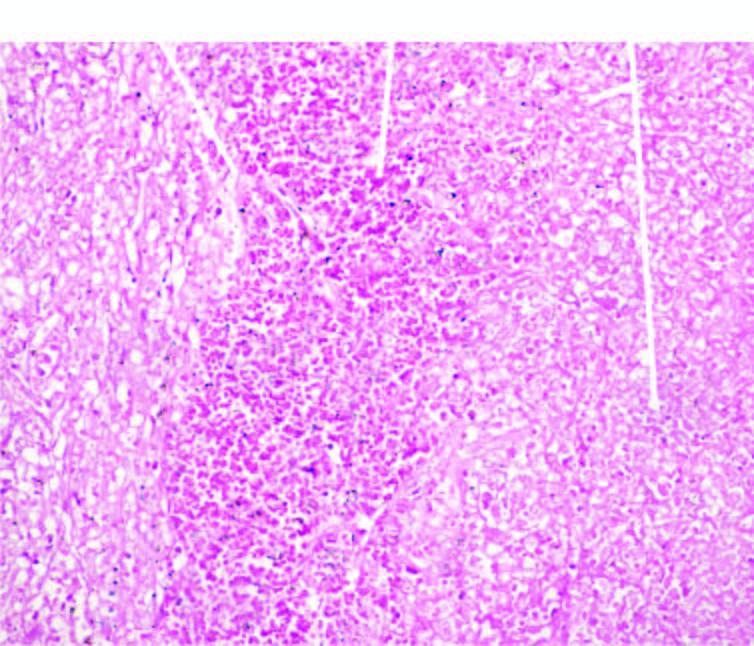what shows haemorrhage?
Answer the question using a single word or phrase. The margin of infracted area 